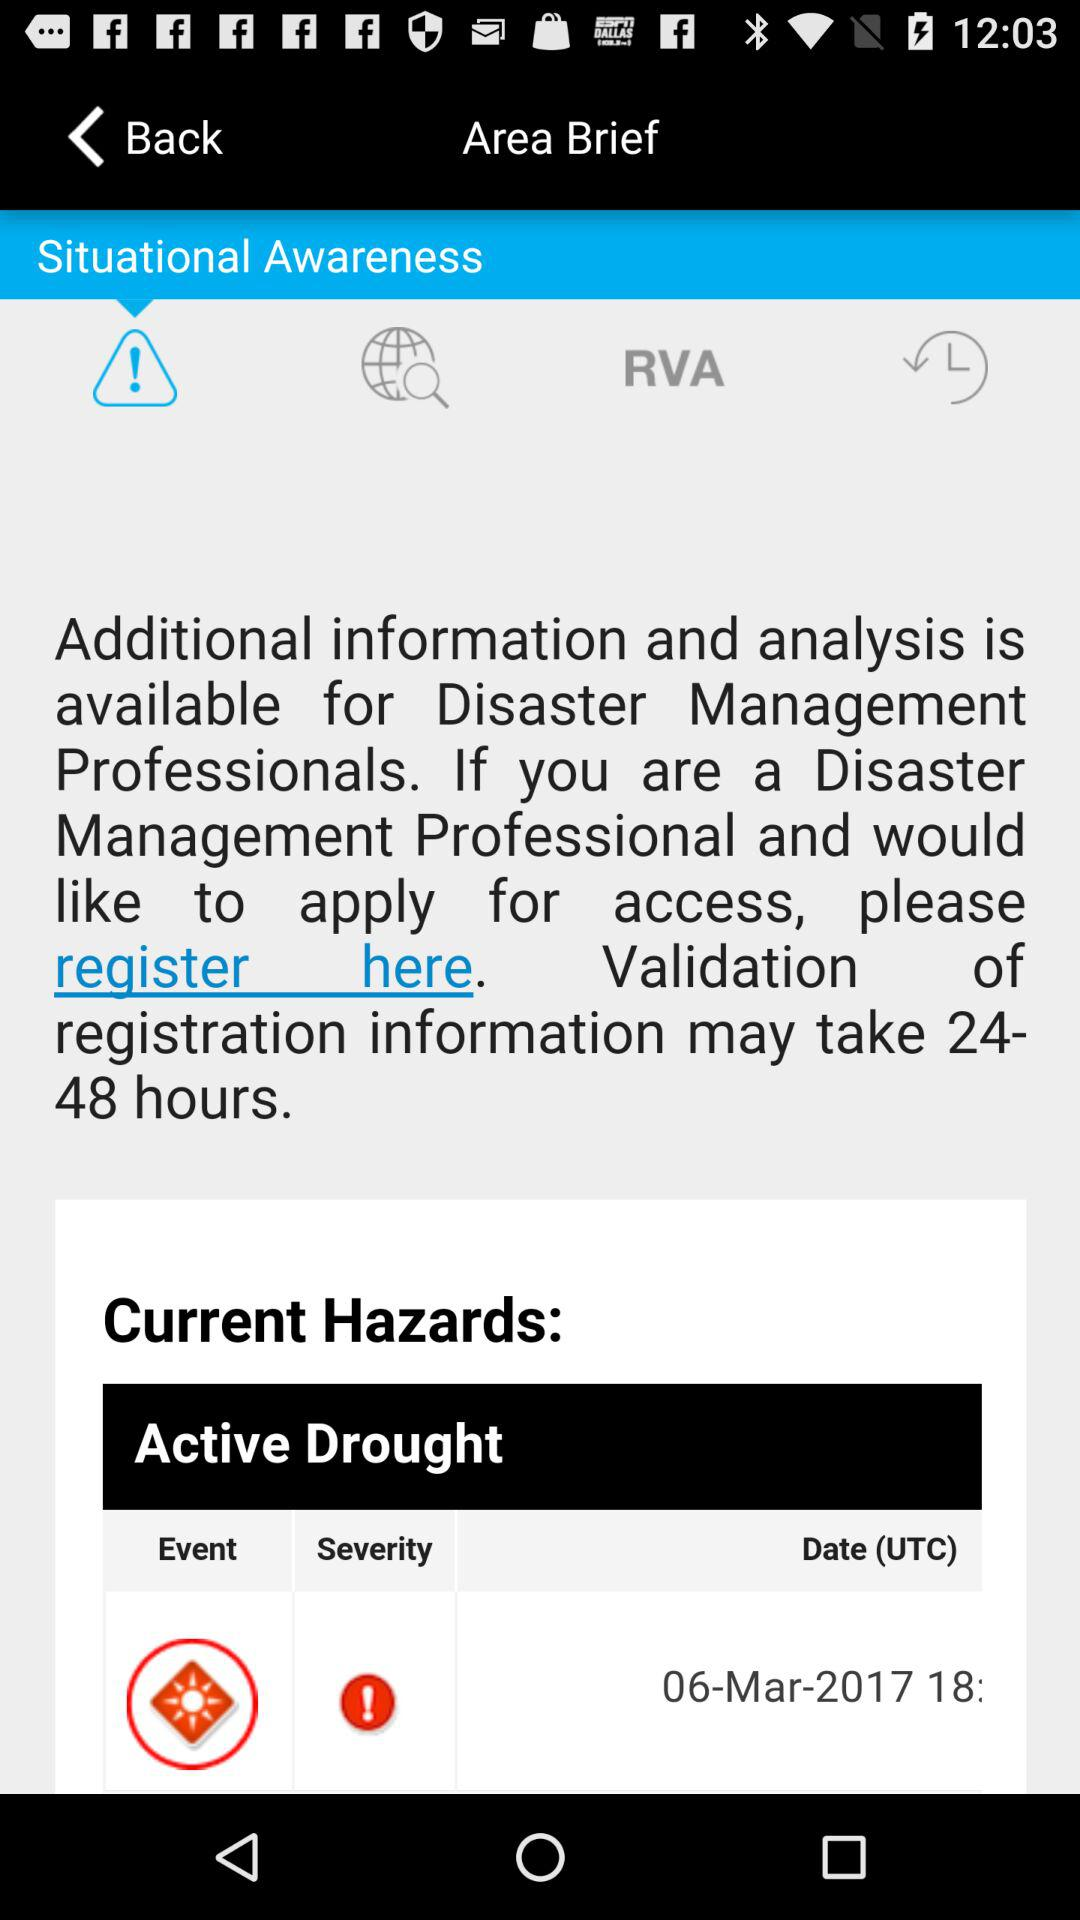What is the date? The date is March 6, 2017. 